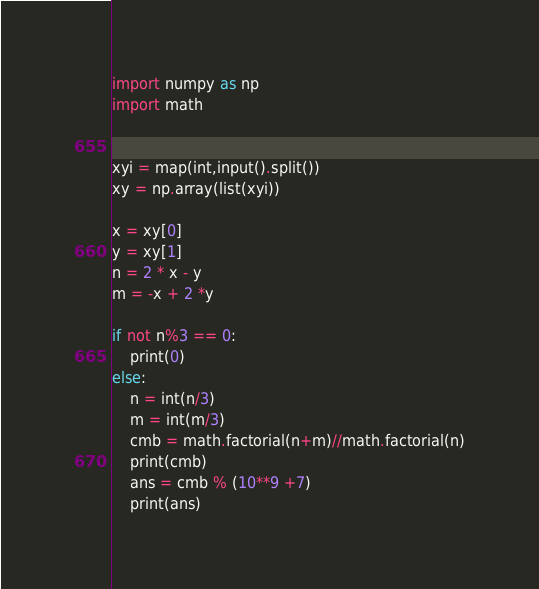Convert code to text. <code><loc_0><loc_0><loc_500><loc_500><_Python_>import numpy as np
import math
 

xyi = map(int,input().split())
xy = np.array(list(xyi))

x = xy[0]
y = xy[1]
n = 2 * x - y
m = -x + 2 *y

if not n%3 == 0:
    print(0)
else:
    n = int(n/3)
    m = int(m/3)
    cmb = math.factorial(n+m)//math.factorial(n)
    print(cmb)
    ans = cmb % (10**9 +7)
    print(ans)</code> 